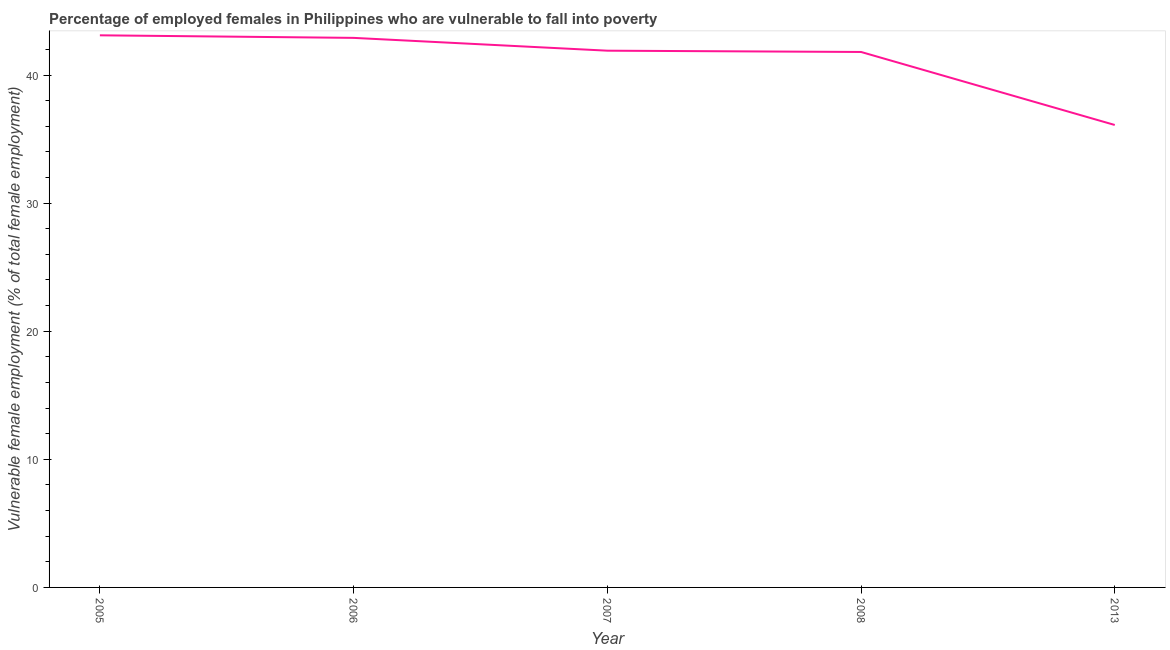What is the percentage of employed females who are vulnerable to fall into poverty in 2005?
Your answer should be very brief. 43.1. Across all years, what is the maximum percentage of employed females who are vulnerable to fall into poverty?
Provide a short and direct response. 43.1. Across all years, what is the minimum percentage of employed females who are vulnerable to fall into poverty?
Make the answer very short. 36.1. What is the sum of the percentage of employed females who are vulnerable to fall into poverty?
Your response must be concise. 205.8. What is the difference between the percentage of employed females who are vulnerable to fall into poverty in 2006 and 2013?
Give a very brief answer. 6.8. What is the average percentage of employed females who are vulnerable to fall into poverty per year?
Offer a terse response. 41.16. What is the median percentage of employed females who are vulnerable to fall into poverty?
Offer a very short reply. 41.9. Do a majority of the years between 2006 and 2007 (inclusive) have percentage of employed females who are vulnerable to fall into poverty greater than 40 %?
Make the answer very short. Yes. What is the ratio of the percentage of employed females who are vulnerable to fall into poverty in 2007 to that in 2008?
Make the answer very short. 1. What is the difference between the highest and the second highest percentage of employed females who are vulnerable to fall into poverty?
Your answer should be compact. 0.2. Is the sum of the percentage of employed females who are vulnerable to fall into poverty in 2006 and 2007 greater than the maximum percentage of employed females who are vulnerable to fall into poverty across all years?
Your answer should be very brief. Yes. In how many years, is the percentage of employed females who are vulnerable to fall into poverty greater than the average percentage of employed females who are vulnerable to fall into poverty taken over all years?
Offer a very short reply. 4. Does the percentage of employed females who are vulnerable to fall into poverty monotonically increase over the years?
Give a very brief answer. No. Are the values on the major ticks of Y-axis written in scientific E-notation?
Provide a succinct answer. No. What is the title of the graph?
Your answer should be very brief. Percentage of employed females in Philippines who are vulnerable to fall into poverty. What is the label or title of the Y-axis?
Ensure brevity in your answer.  Vulnerable female employment (% of total female employment). What is the Vulnerable female employment (% of total female employment) in 2005?
Offer a very short reply. 43.1. What is the Vulnerable female employment (% of total female employment) of 2006?
Ensure brevity in your answer.  42.9. What is the Vulnerable female employment (% of total female employment) of 2007?
Offer a very short reply. 41.9. What is the Vulnerable female employment (% of total female employment) in 2008?
Ensure brevity in your answer.  41.8. What is the Vulnerable female employment (% of total female employment) in 2013?
Keep it short and to the point. 36.1. What is the difference between the Vulnerable female employment (% of total female employment) in 2005 and 2008?
Give a very brief answer. 1.3. What is the difference between the Vulnerable female employment (% of total female employment) in 2006 and 2007?
Ensure brevity in your answer.  1. What is the difference between the Vulnerable female employment (% of total female employment) in 2007 and 2008?
Give a very brief answer. 0.1. What is the difference between the Vulnerable female employment (% of total female employment) in 2007 and 2013?
Ensure brevity in your answer.  5.8. What is the ratio of the Vulnerable female employment (% of total female employment) in 2005 to that in 2007?
Keep it short and to the point. 1.03. What is the ratio of the Vulnerable female employment (% of total female employment) in 2005 to that in 2008?
Ensure brevity in your answer.  1.03. What is the ratio of the Vulnerable female employment (% of total female employment) in 2005 to that in 2013?
Make the answer very short. 1.19. What is the ratio of the Vulnerable female employment (% of total female employment) in 2006 to that in 2007?
Keep it short and to the point. 1.02. What is the ratio of the Vulnerable female employment (% of total female employment) in 2006 to that in 2013?
Your answer should be very brief. 1.19. What is the ratio of the Vulnerable female employment (% of total female employment) in 2007 to that in 2008?
Your response must be concise. 1. What is the ratio of the Vulnerable female employment (% of total female employment) in 2007 to that in 2013?
Keep it short and to the point. 1.16. What is the ratio of the Vulnerable female employment (% of total female employment) in 2008 to that in 2013?
Your answer should be very brief. 1.16. 